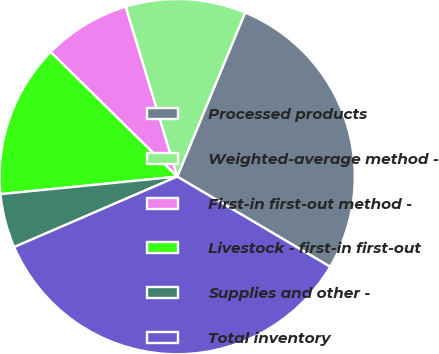Convert chart to OTSL. <chart><loc_0><loc_0><loc_500><loc_500><pie_chart><fcel>Processed products<fcel>Weighted-average method -<fcel>First-in first-out method -<fcel>Livestock - first-in first-out<fcel>Supplies and other -<fcel>Total inventory<nl><fcel>27.23%<fcel>10.94%<fcel>7.93%<fcel>13.95%<fcel>4.92%<fcel>35.03%<nl></chart> 